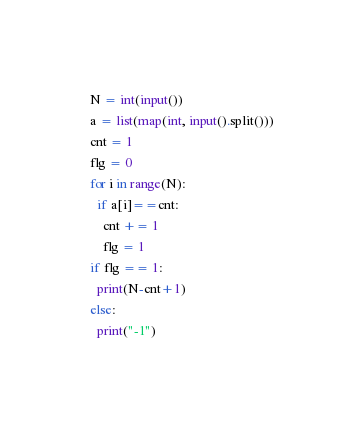Convert code to text. <code><loc_0><loc_0><loc_500><loc_500><_Python_>N = int(input())
a = list(map(int, input().split()))
cnt = 1
flg = 0
for i in range(N):
  if a[i]==cnt:
    cnt += 1
    flg = 1
if flg == 1:
  print(N-cnt+1)
else:
  print("-1")</code> 